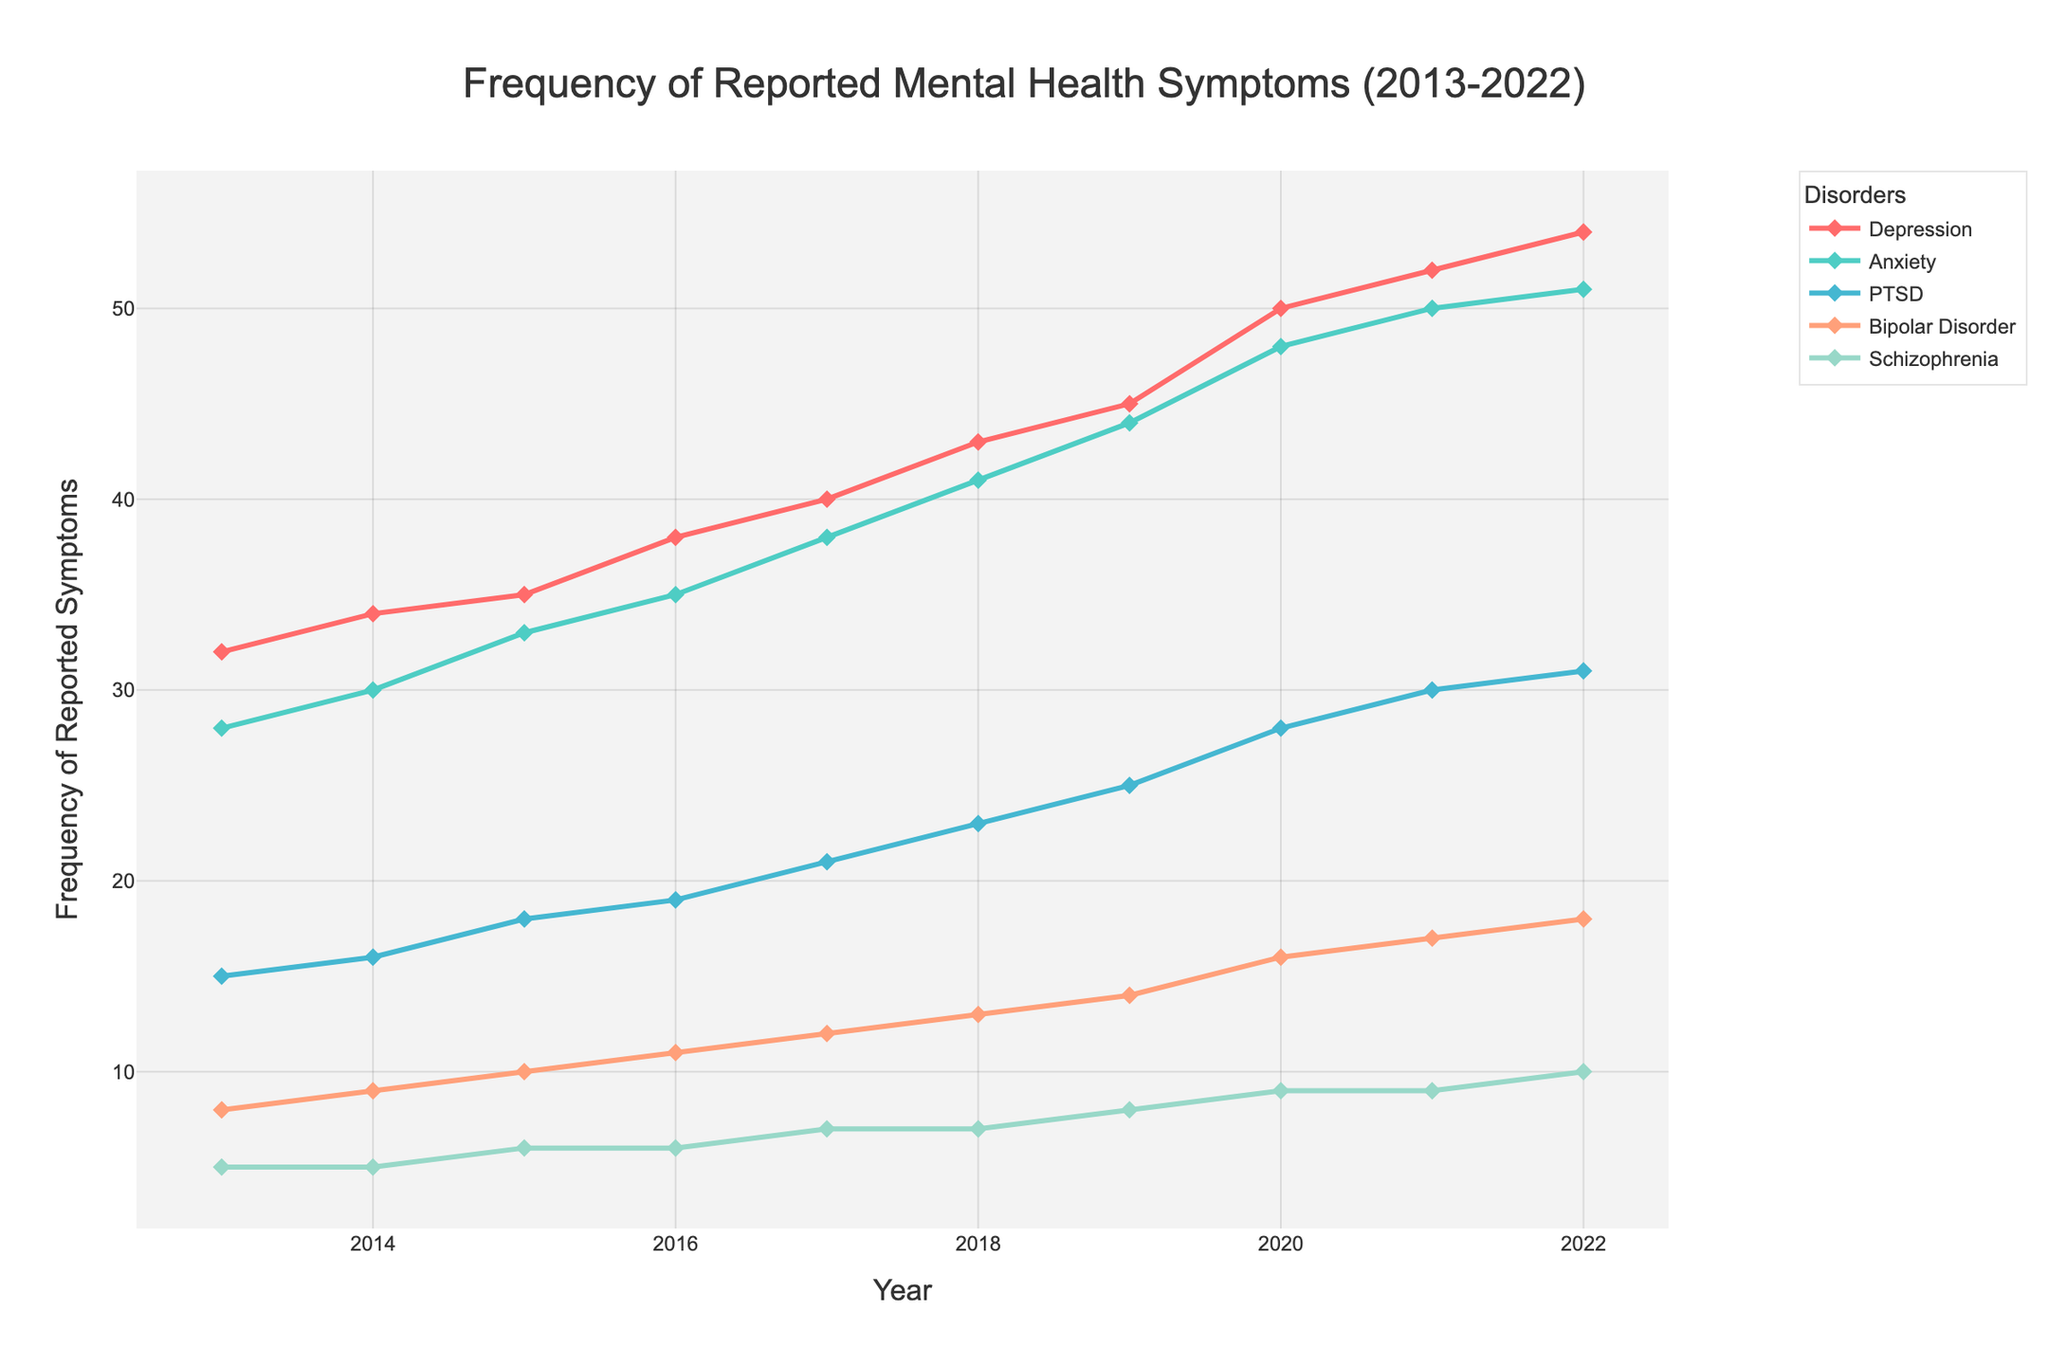What is the general trend of reported symptoms for Depression over the 10-year period? View the line representing Depression; observe that it increases steadily from 32 in 2013 to 54 in 2022.
Answer: Increasing In which year did Anxiety and Depression have the same frequency of reported symptoms? Look for the intersections between the lines representing Anxiety and Depression. There are no intersections indicating equal values, which means they never had the same frequency.
Answer: Never Which mental disorder had the highest increase in reported symptoms from 2013 to 2022? Calculate the difference for each disorder between their values in 2013 and 2022, then identify the highest difference: Depression (54-32=22), Anxiety (51-28=23), PTSD (31-15=16), Bipolar Disorder (18-8=10), Schizophrenia (10-5=5).
Answer: Anxiety What was the frequency difference between PTSD and Schizophrenia in 2020? Subtract the value of Schizophrenia from the value of PTSD for the year 2020: 28 (PTSD) - 9 (Schizophrenia).
Answer: 19 Compare the frequencies of Bipolar Disorder and PTSD in 2016. Which one was higher and by how much? Check the plotted values for Bipolar Disorder and PTSD in 2016: Bipolar Disorder (11), PTSD (19). Subtract Bipolar Disorder from PTSD: 19 - 11.
Answer: PTSD was higher by 8 What is the average annual increase in reported symptoms for Schizophrenia from 2013 to 2022? Calculate the total increase and divide by the number of years (2022-2013=9): The total increase is 10-5=5; the average increase is 5/9.
Answer: Approximately 0.56 Which year saw the highest jump in reported symptoms for Bipolar Disorder? Find the year-to-year differences and identify the largest change: 2013-2014 (1), 2014-2015 (1), 2015-2016 (1), 2016-2017 (1), 2017-2018 (1), 2018-2019 (1), 2019-2020 (2), 2020-2021 (1), 2021-2022 (1).
Answer: 2019 to 2020 How many disorders reported a frequency of symptoms greater than 40 in 2022? Check each disorder's value for 2022 and count those greater than 40: Depression (54), Anxiety (51).
Answer: 2 What is the overall trend for the frequency of reported symptoms for PTSD? Look at the line representing PTSD, which shows a steady increase from 15 in 2013 to 31 in 2022.
Answer: Increasing Which disorder had the smallest frequency of reported symptoms in 2015? Identify the lowest value among all disorders for the year 2015: Depression (35), Anxiety (33), PTSD (18), Bipolar Disorder (10), Schizophrenia (6).
Answer: Schizophrenia 